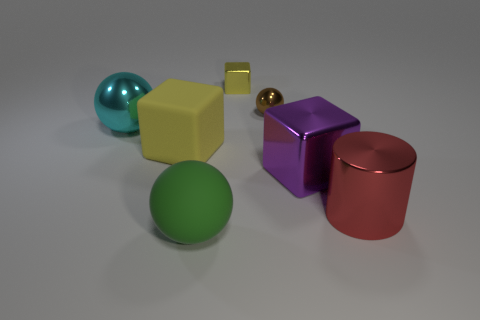Is the yellow block that is in front of the tiny sphere made of the same material as the red object?
Your answer should be compact. No. Is there anything else that is the same material as the purple thing?
Your response must be concise. Yes. How many big objects are to the left of the shiny ball on the right side of the rubber thing that is in front of the red object?
Your answer should be very brief. 3. There is a metallic object that is on the left side of the green object; is it the same shape as the purple object?
Ensure brevity in your answer.  No. How many objects are either large yellow shiny cylinders or metal things behind the yellow matte cube?
Give a very brief answer. 3. Are there more big metallic spheres right of the red shiny cylinder than metallic things?
Keep it short and to the point. No. Are there an equal number of large metallic balls that are in front of the green thing and big shiny things that are left of the small yellow block?
Give a very brief answer. No. Are there any cylinders behind the large cyan sphere on the left side of the red shiny thing?
Provide a succinct answer. No. The large cyan thing has what shape?
Give a very brief answer. Sphere. There is a shiny cube that is the same color as the rubber block; what is its size?
Your answer should be very brief. Small. 